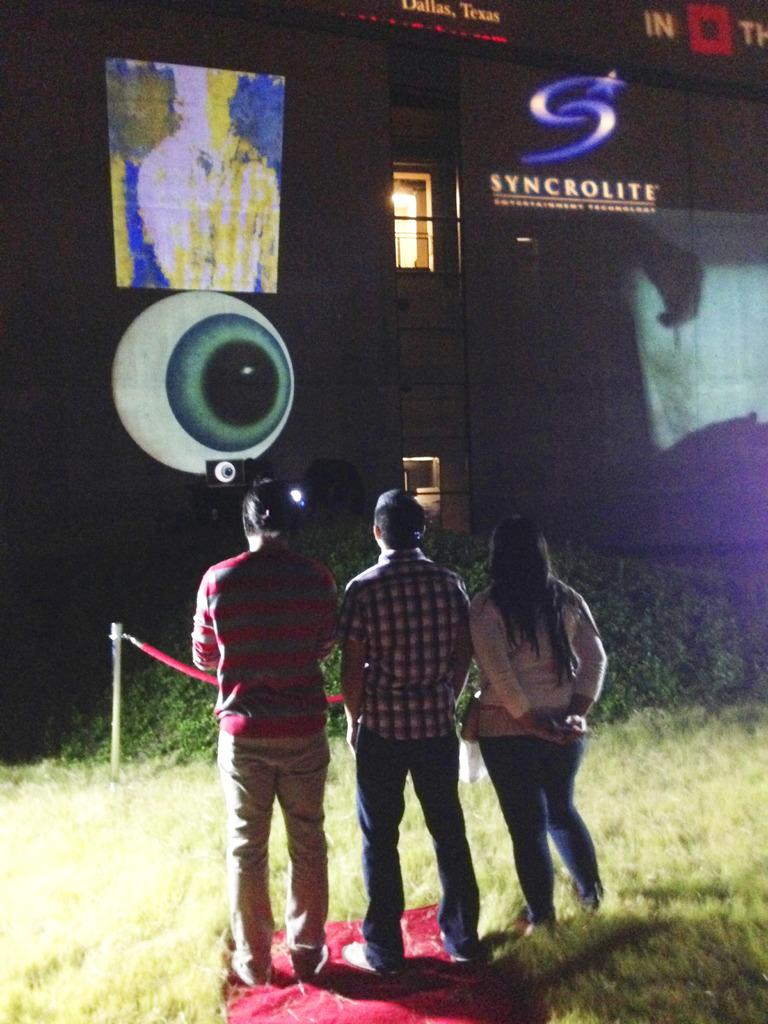How many people are present in the image? There are three people in the image. What can be seen on the wall in front of the people? There are texts and images on the wall in the image. What type of vegetation is present in the image? There are plants and grass in the image. What architectural feature is visible in the image? There is a window in the image. What equipment is used for displaying visuals in the image? There is a projector in the image. What device is used for amplifying sound in the image? There is a speaker in the image. What type of tin can be seen in the pocket of one of the people in the image? There is no tin or pocket visible in the image; it only shows three people, texts and images on the wall, plants and grass, a window, a projector, and a speaker. 